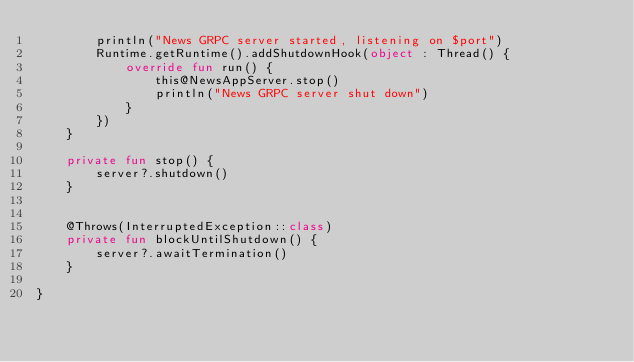<code> <loc_0><loc_0><loc_500><loc_500><_Kotlin_>        println("News GRPC server started, listening on $port")
        Runtime.getRuntime().addShutdownHook(object : Thread() {
            override fun run() {
                this@NewsAppServer.stop()
                println("News GRPC server shut down")
            }
        })
    }

    private fun stop() {
        server?.shutdown()
    }


    @Throws(InterruptedException::class)
    private fun blockUntilShutdown() {
        server?.awaitTermination()
    }

}</code> 